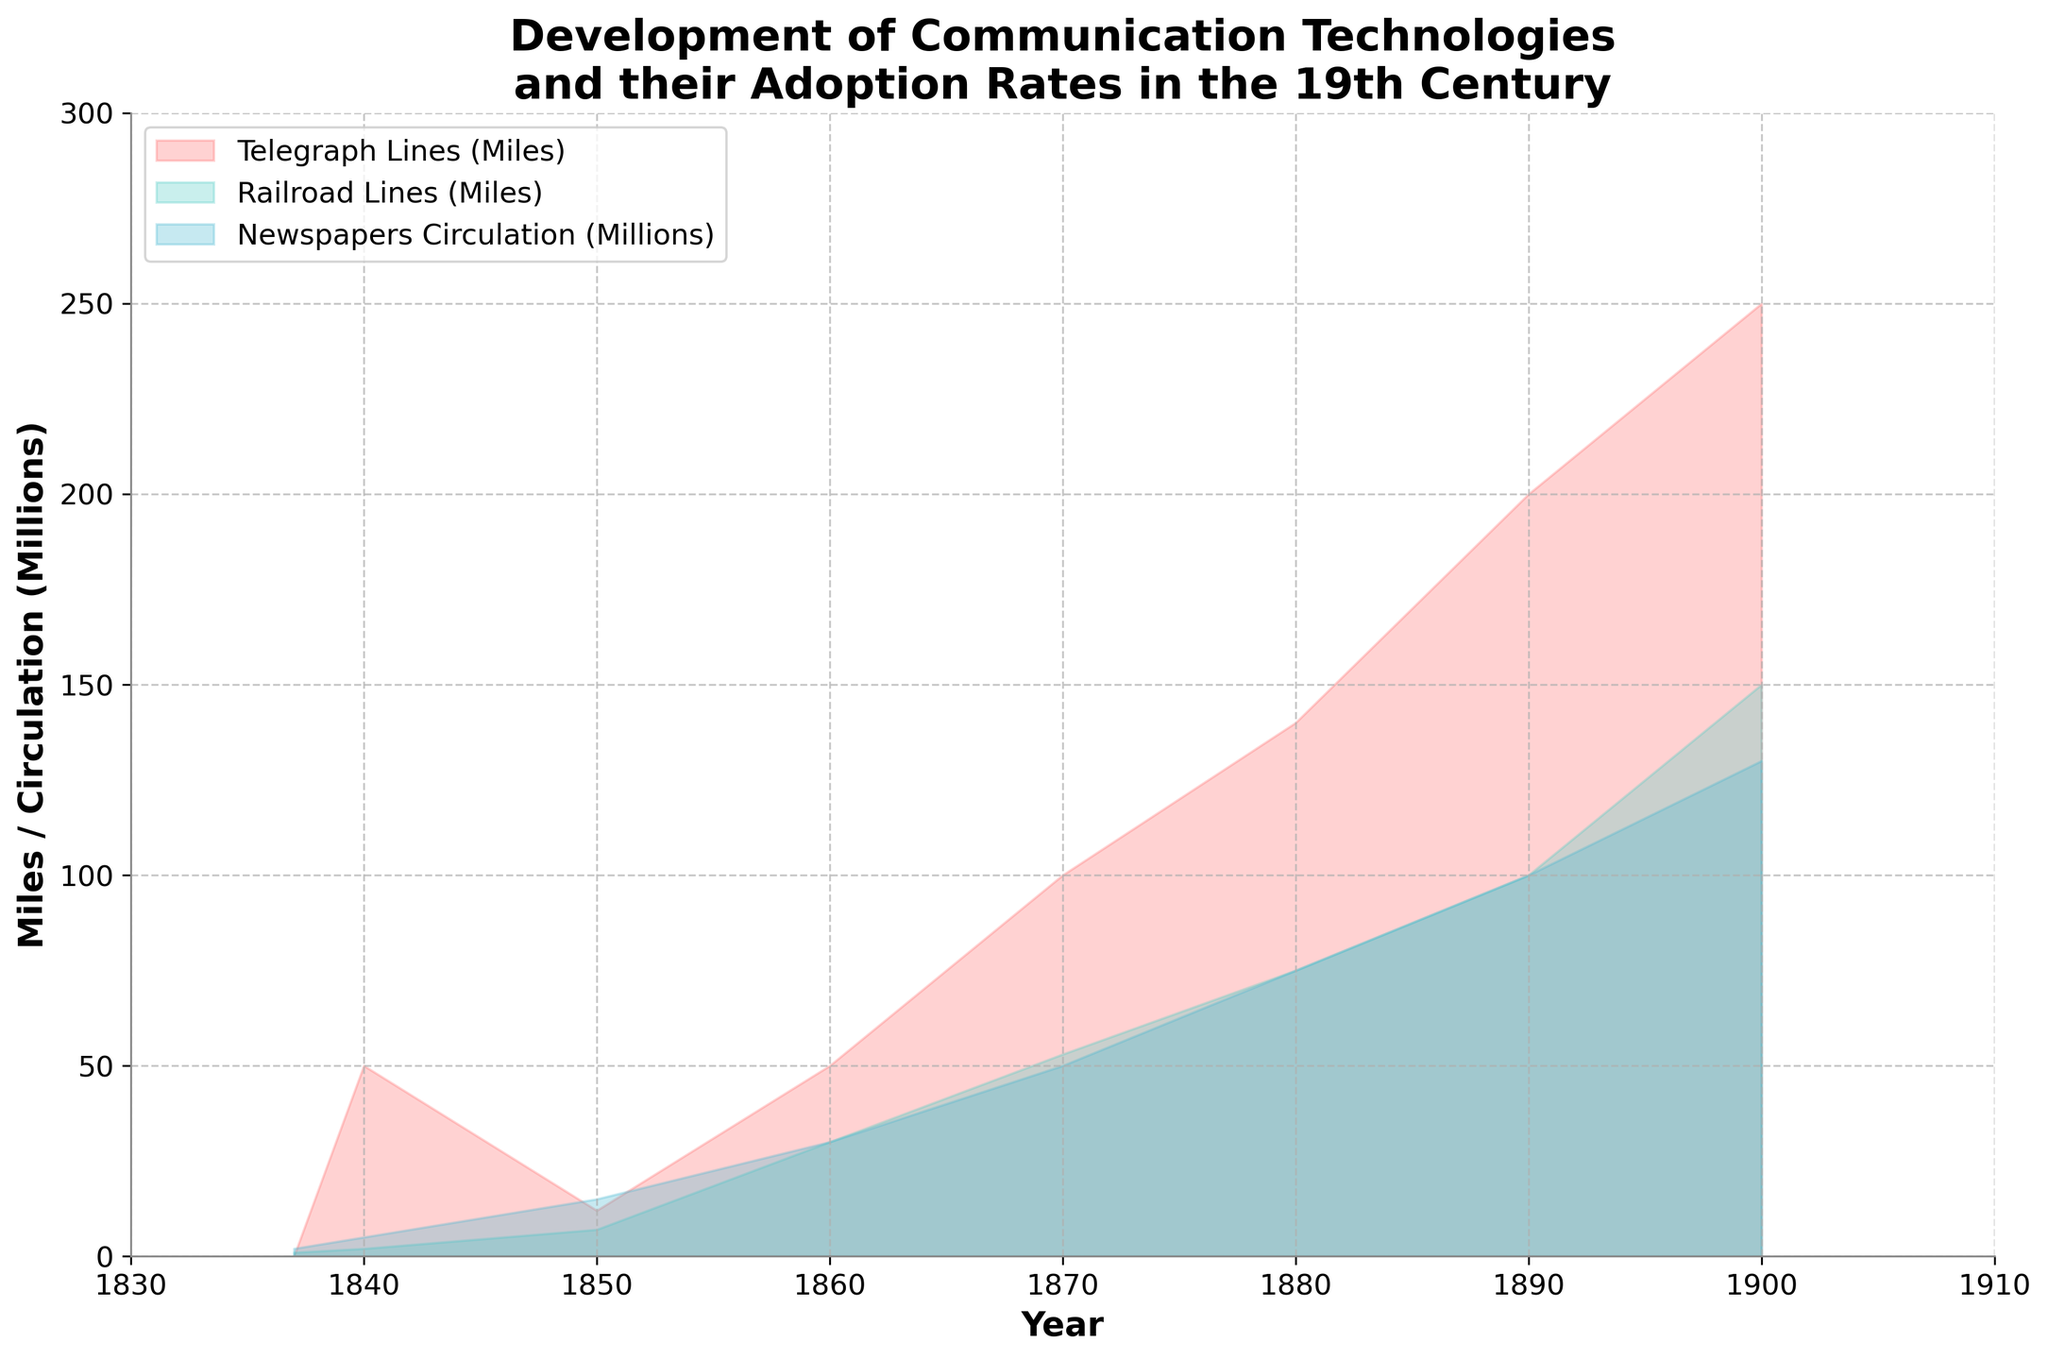What is the title of the figure? The title of the figure is displayed prominently at the top. It reads "Development of Communication Technologies and their Adoption Rates in the 19th Century."
Answer: Development of Communication Technologies and their Adoption Rates in the 19th Century What is the range of years shown in the figure? The x-axis of the figure is labeled "Year" and spans from 1830 to 1910. This can be observed by looking at the figure's x-axis limits.
Answer: 1830 to 1910 What color represents the telegraph lines in the chart? The color representing the telegraph lines is a red shade, as indicated in the legend labeled "Telegraph Lines (Miles)."
Answer: Red What is the newspaper circulation in the year 1860? By observing the figure and looking at the area chart for newspapers, we can see that newspaper circulation in 1860 is marked at approximately 30 million.
Answer: 30 million How many data points are represented in the figure? By counting each unique year provided along the x-axis, we can determine that there are eight data points: 1837, 1840, 1850, 1860, 1870, 1880, 1890, and 1900.
Answer: Eight What was the state of telegraph line adoption in 1840 compared to railroad lines? Observing the filled areas for both telegraph and railroad lines in 1840, we see that telegraph lines were at 50 miles while railroad lines were at 2 miles. Therefore, telegraph lines were more widely adopted than railroad lines in 1840.
Answer: Telegraph lines were more widely adopted Between which two consecutive decades did the telegraph lines see the most significant growth? By looking at the figure, we can see the steepest increase in the telegraph lines between 1890 and 1900. The growth is from 200 miles to 250 miles, which is an increase of 50 miles.
Answer: 1890 to 1900 What is the approximate average railroad line length between 1850 and 1900? To find the average, add the railroad lengths for the years 1850 to 1900 (7 + 30 + 53 + 75 + 100 + 150 = 415) and divide by the number of years (6). The average is approximately 69.17 miles.
Answer: Approximately 69.17 miles Which technology had the highest adoption rate by the year 1900? By observing the filled areas at the year 1900, we see that newspapers had the highest value at 130 million in circulation, compared to telegraph lines at 250 miles and railroad lines at 150 miles.
Answer: Newspapers How did the adoption of newspapers compare to railroads in the year 1870? In 1870, the newspaper circulation can be seen at 50 million while the railroad lines are marked at 53 miles. Thus, newspapers had slightly lower adoption compared to railroads in 1870.
Answer: Newspapers had slightly lower adoption 